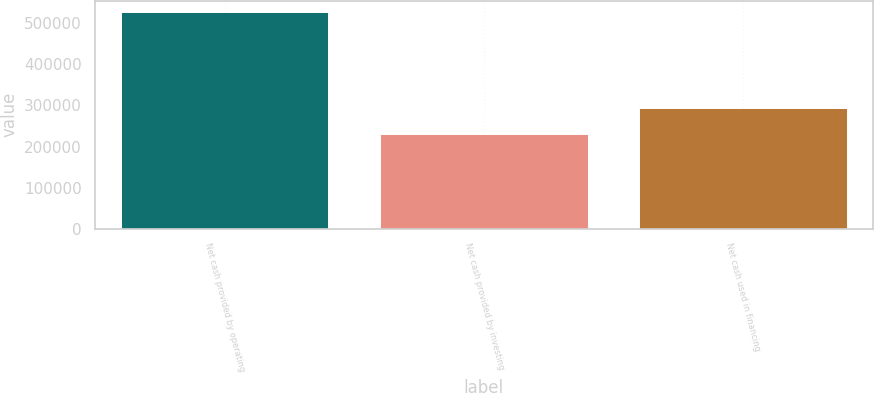<chart> <loc_0><loc_0><loc_500><loc_500><bar_chart><fcel>Net cash provided by operating<fcel>Net cash provided by investing<fcel>Net cash used in financing<nl><fcel>527979<fcel>229756<fcel>293443<nl></chart> 